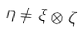Convert formula to latex. <formula><loc_0><loc_0><loc_500><loc_500>\eta \neq \xi \otimes \zeta</formula> 